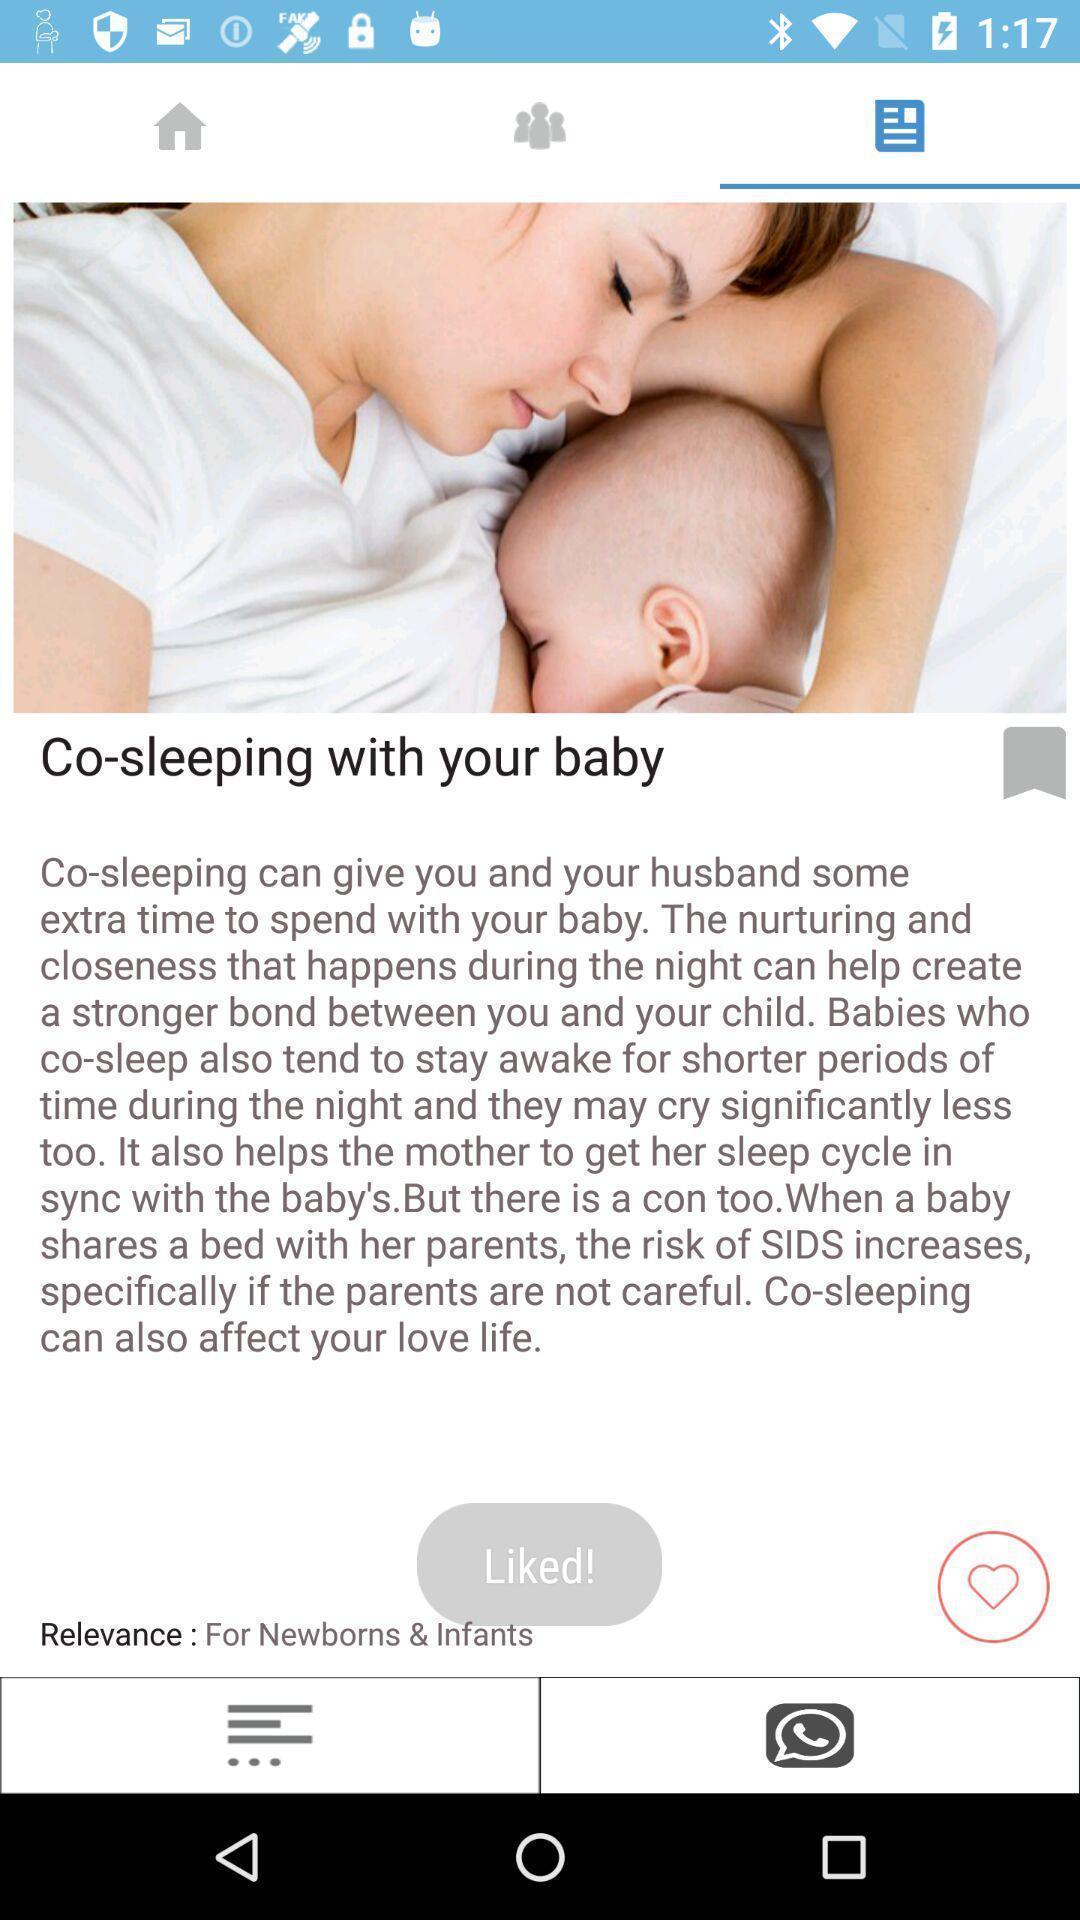Describe this image in words. Page showing information about baby sleep. 